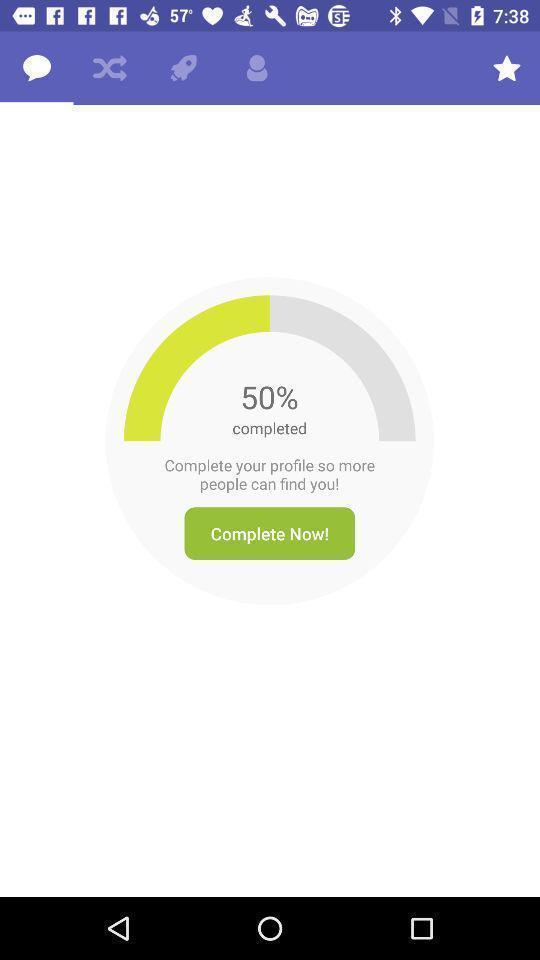Explain the elements present in this screenshot. Screen displaying the notification to complete my profile. 